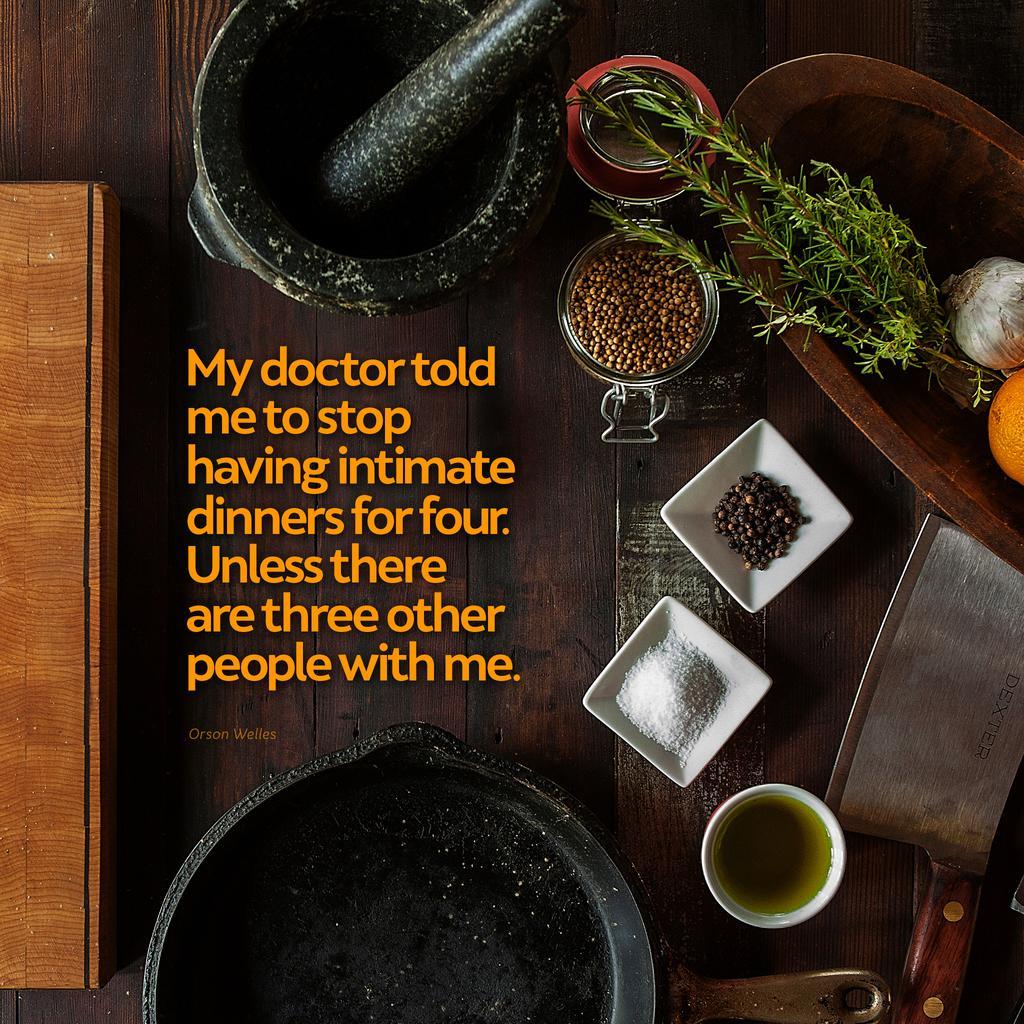Could you give a brief overview of what you see in this image? In the image we can see there are kitchen things, there is a wooden surface, stone, bowl, knife, pan, leaves, jar, garlic and orange. 